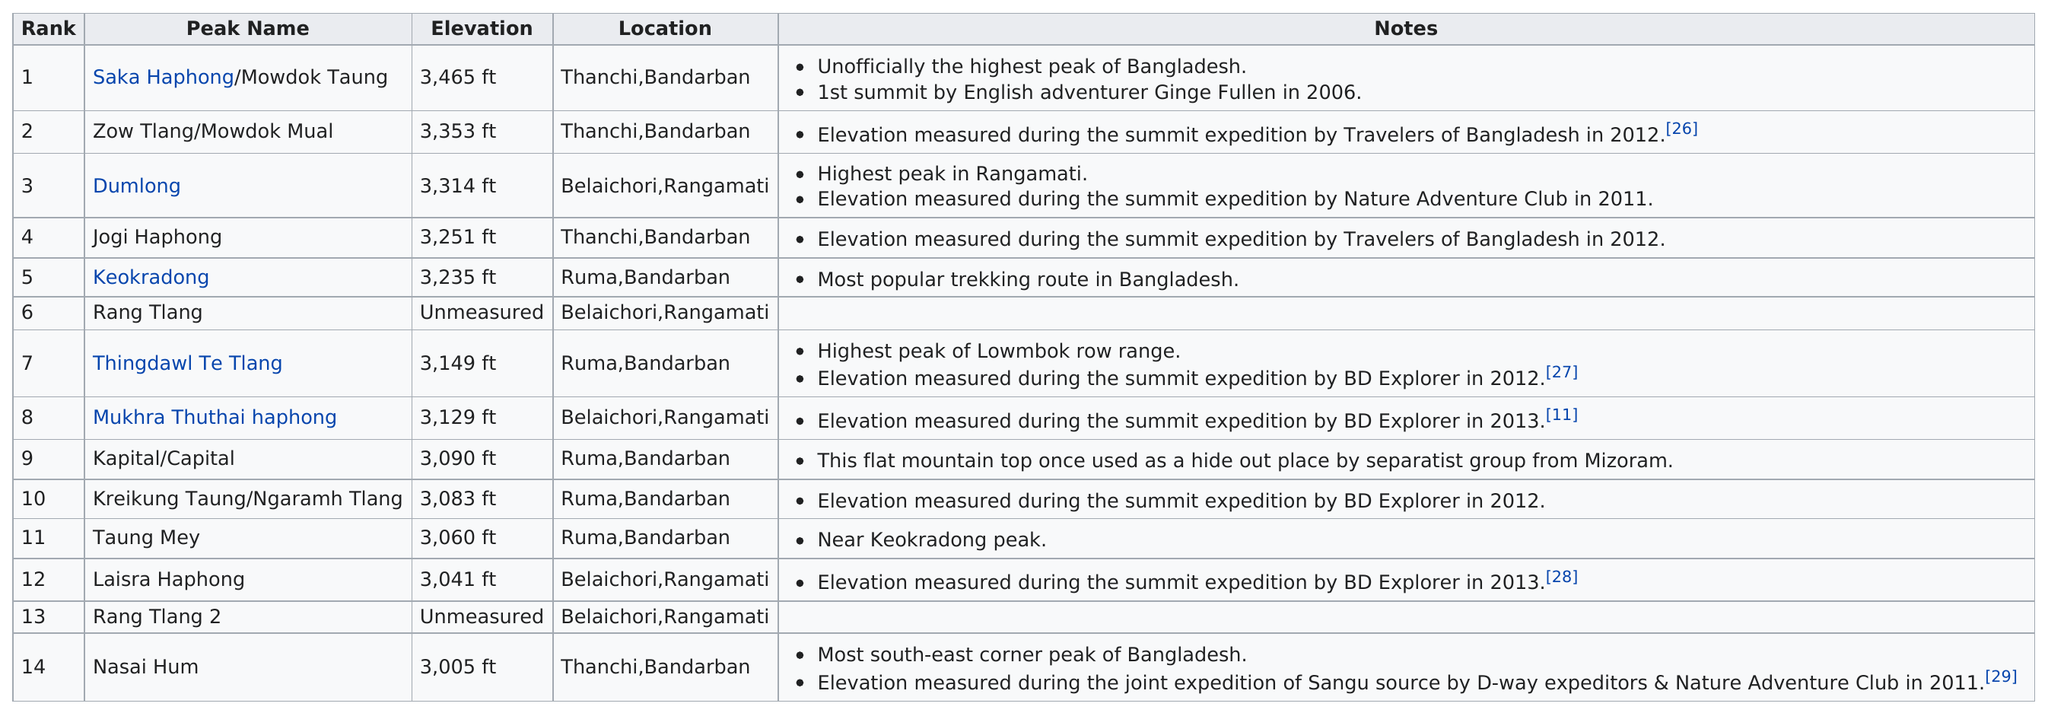Give some essential details in this illustration. The Rang Tlang peak is the only unmeasured peak in the graph. There are five peaks that have an elevation of at least 3,200 feet. There are four peaks that are taller than Mount Keokradong. There are a significant number of mountains located in Ruma and Bandarban. Dumlong is not the tallest peak among two peaks, Saka Haphong/Mowdok Taung and Zow Tlang/Mowdok Mual are taller than Dumlong. 